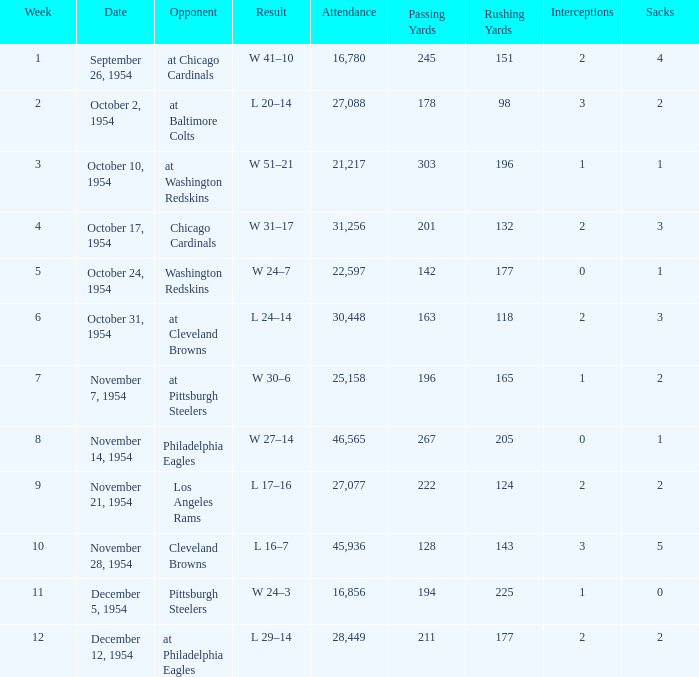How many weeks have october 31, 1954 as the date? 1.0. 